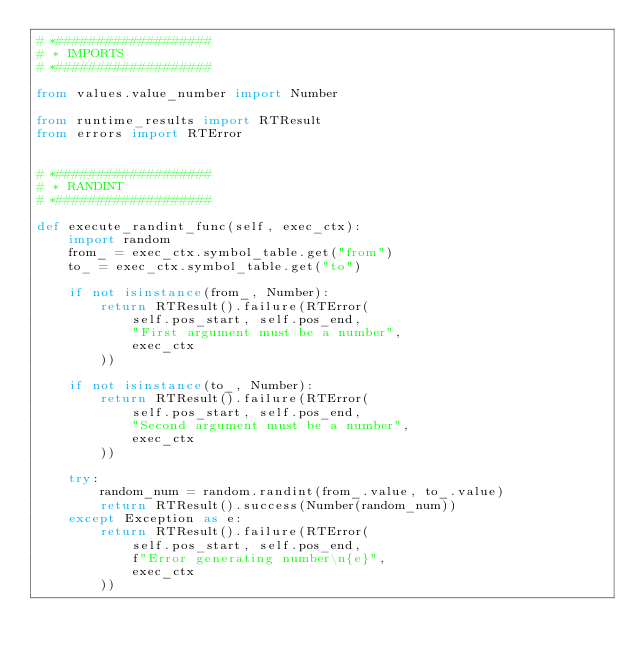<code> <loc_0><loc_0><loc_500><loc_500><_Python_># *###################
# * IMPORTS
# *###################

from values.value_number import Number

from runtime_results import RTResult
from errors import RTError


# *###################
# * RANDINT
# *###################

def execute_randint_func(self, exec_ctx):
    import random
    from_ = exec_ctx.symbol_table.get("from")
    to_ = exec_ctx.symbol_table.get("to")

    if not isinstance(from_, Number):
        return RTResult().failure(RTError(
            self.pos_start, self.pos_end,
            "First argument must be a number",
            exec_ctx
        ))

    if not isinstance(to_, Number):
        return RTResult().failure(RTError(
            self.pos_start, self.pos_end,
            "Second argument must be a number",
            exec_ctx
        ))

    try:
        random_num = random.randint(from_.value, to_.value)
        return RTResult().success(Number(random_num))
    except Exception as e:
        return RTResult().failure(RTError(
            self.pos_start, self.pos_end,
            f"Error generating number\n{e}",
            exec_ctx
        ))</code> 